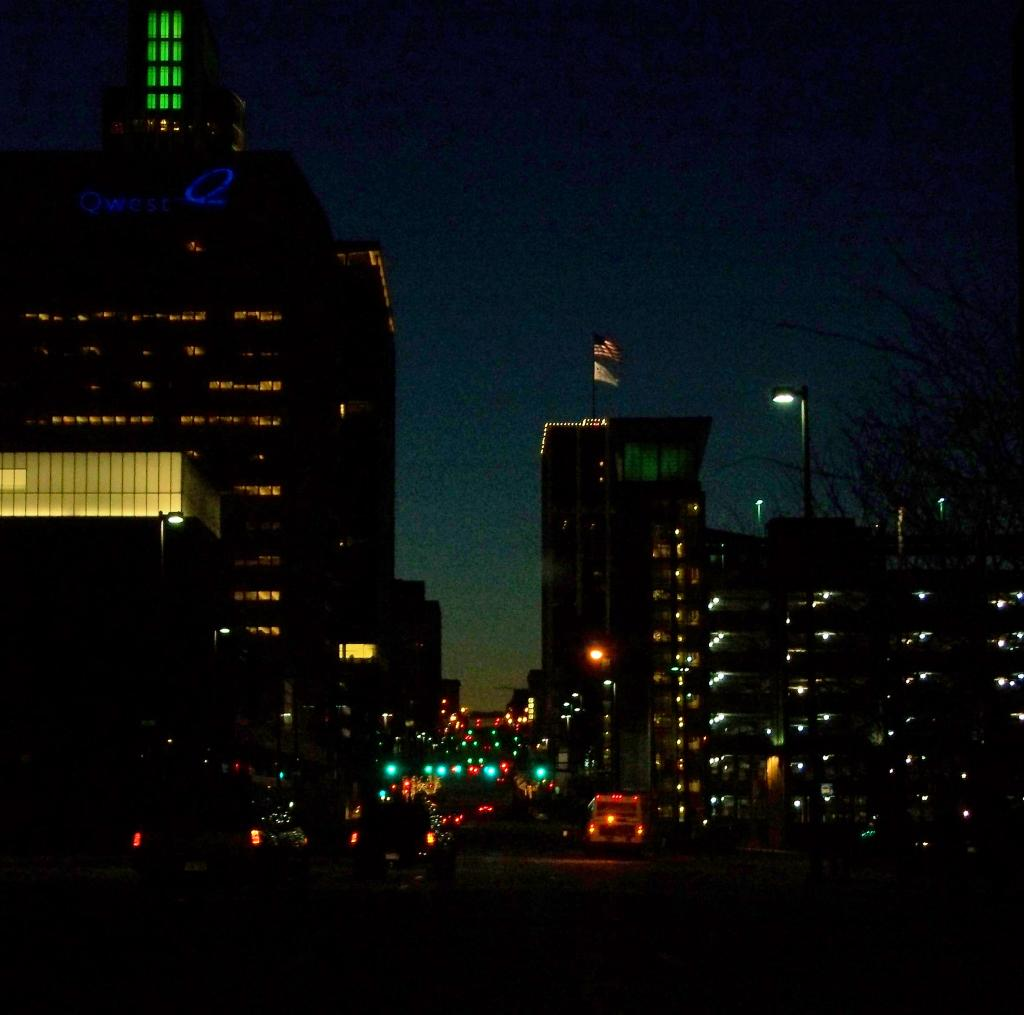What type of structures can be seen in the image? There are buildings in the image. What is happening on the road in the image? There are vehicles moving on the road in the image. What is the tall, thin object in the image? There is a pole in the image. What type of vegetation is present in the image? There are trees in the image. What type of wing can be seen on the trees in the image? There are no wings present on the trees in the image; they are regular trees. What song is being played in the background of the image? There is no information about any song being played in the image. 